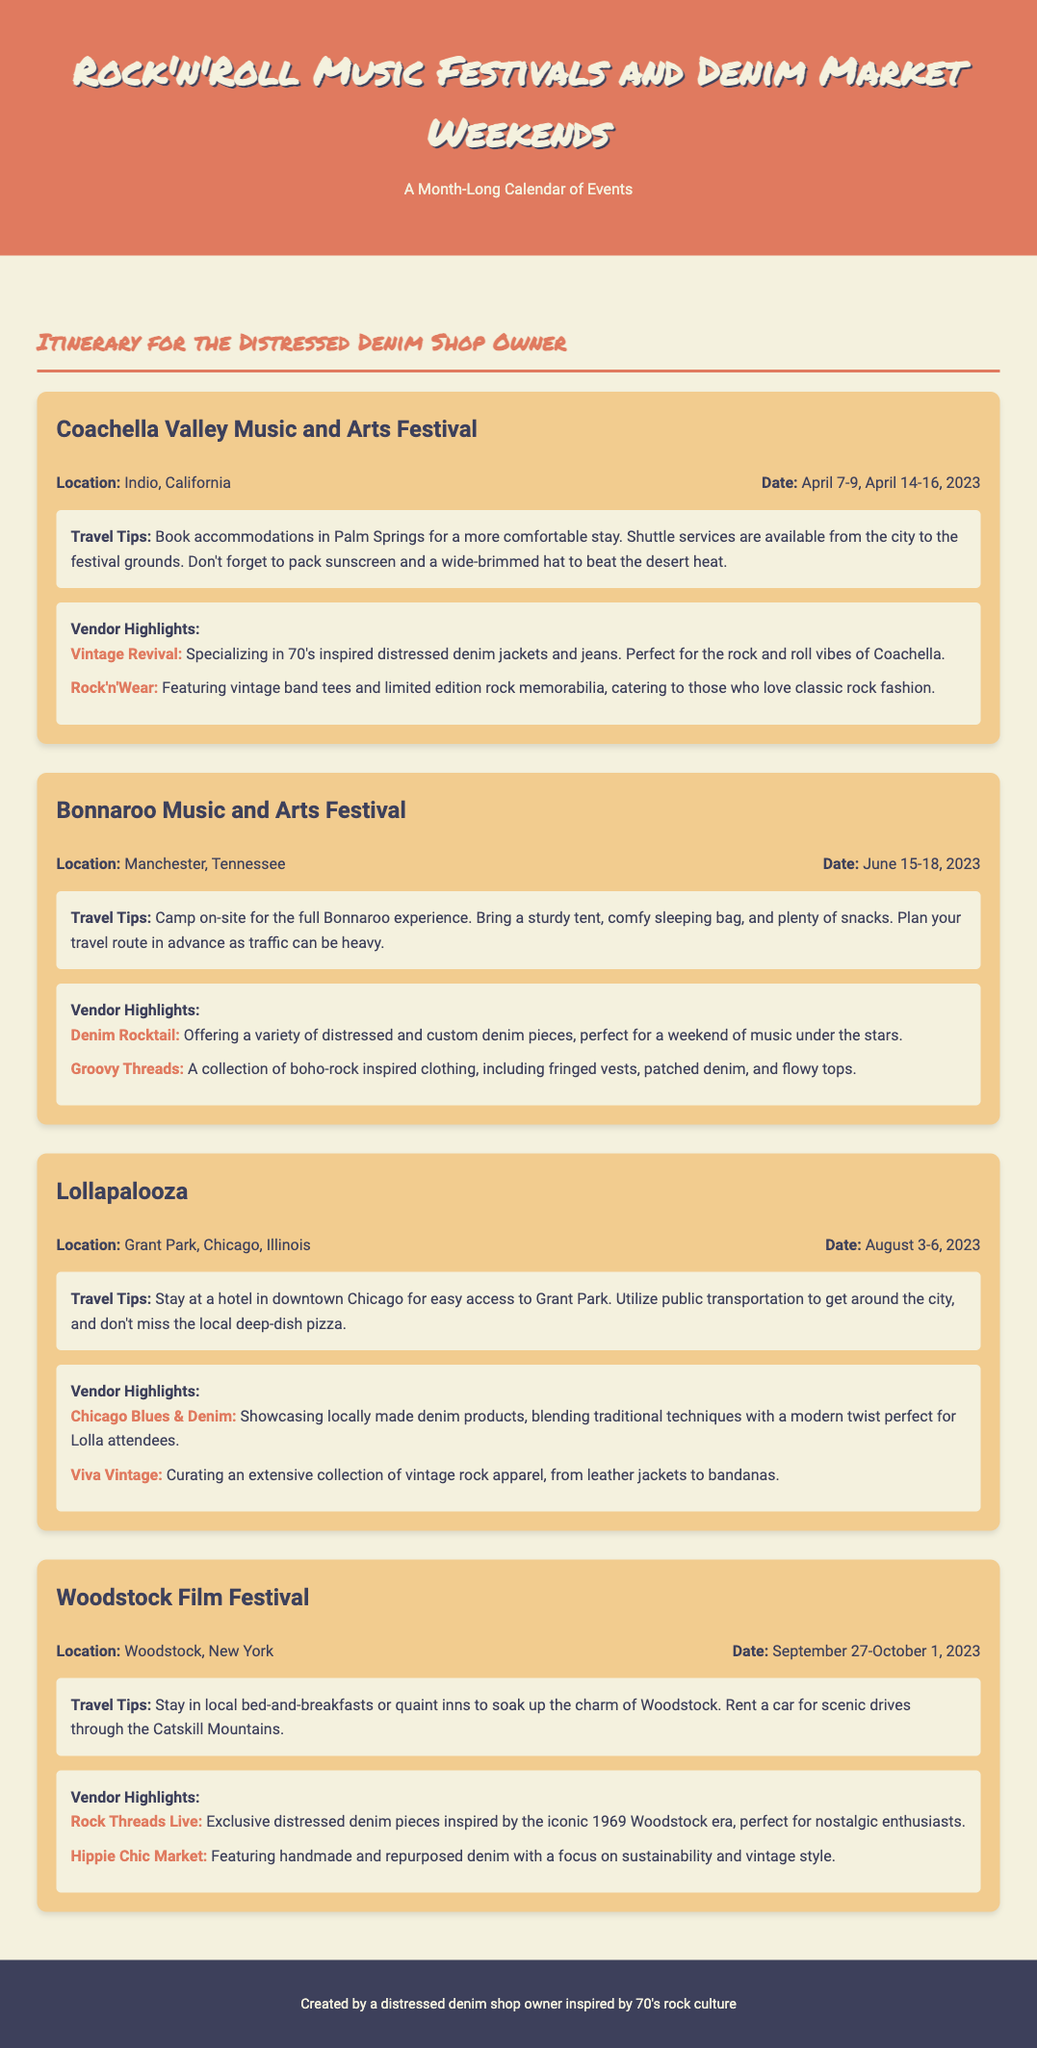what is the location of Coachella Valley Music and Arts Festival? The document states that the location is Indio, California.
Answer: Indio, California what are the dates for the Woodstock Film Festival? The document mentions that the dates are September 27-October 1, 2023.
Answer: September 27-October 1, 2023 which vendor specializes in 70's inspired distressed denim jackets at Coachella? The document highlights Vintage Revival for specializing in 70's inspired distressed denim jackets and jeans.
Answer: Vintage Revival how many days is the Bonnaroo Music and Arts Festival? The document notes that Bonnaroo spans four days, from June 15-18, 2023.
Answer: Four days what is a recommended travel tip for Lollapalooza? According to the document, a travel tip is to utilize public transportation to get around the city.
Answer: Utilize public transportation which vendor offers handmade and repurposed denim at the Woodstock Film Festival? The document indicates that Hippie Chic Market features handmade and repurposed denim.
Answer: Hippie Chic Market why should I stay in Palm Springs for Coachella? The document suggests that Palm Springs offers a more comfortable stay compared to other locations.
Answer: More comfortable stay what type of clothing does Groovy Threads offer at Bonnaroo? The document describes Groovy Threads as a collection of boho-rock inspired clothing.
Answer: Boho-rock inspired clothing 